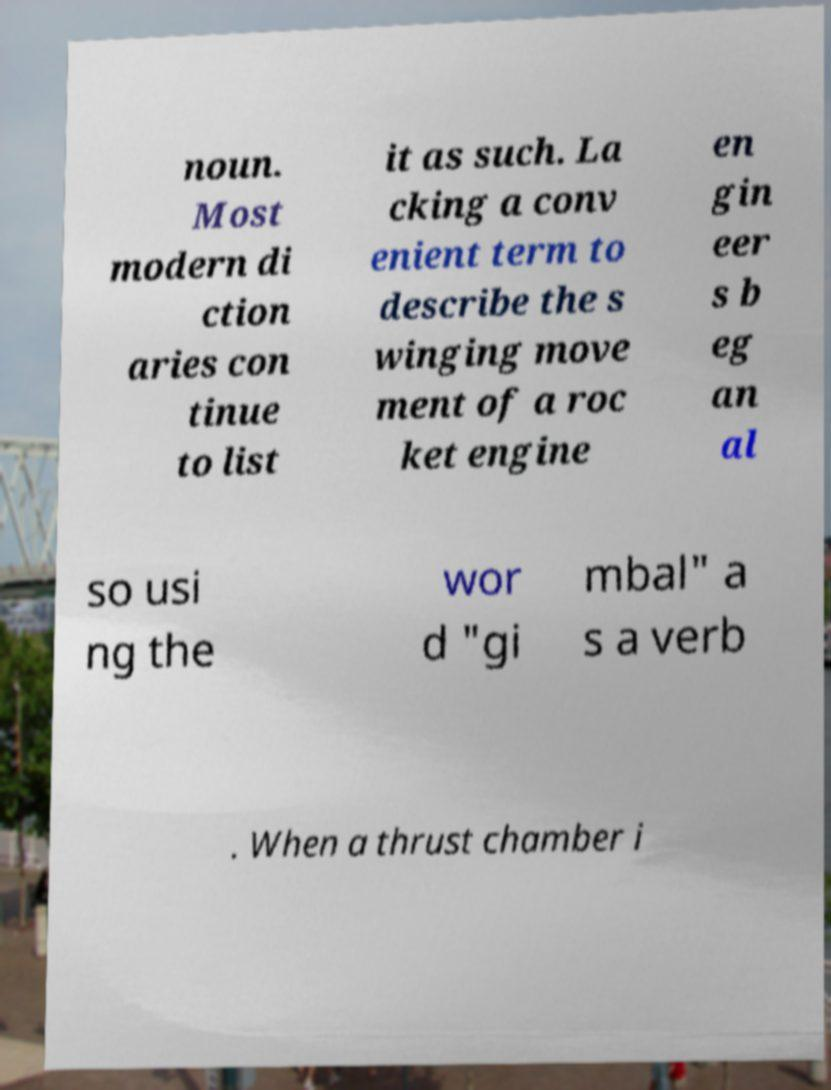For documentation purposes, I need the text within this image transcribed. Could you provide that? noun. Most modern di ction aries con tinue to list it as such. La cking a conv enient term to describe the s winging move ment of a roc ket engine en gin eer s b eg an al so usi ng the wor d "gi mbal" a s a verb . When a thrust chamber i 